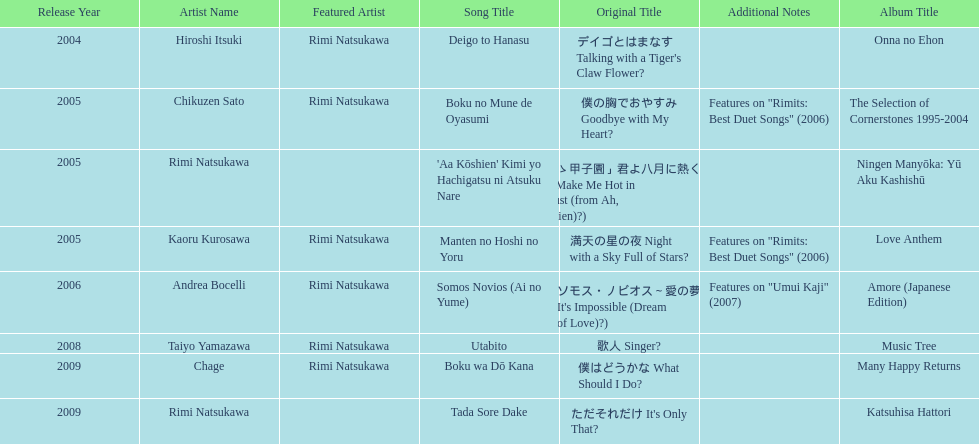Which title has the same notes as night with a sky full of stars? Boku no Mune de Oyasumi (僕の胸でおやすみ Goodbye with My Heart?). Parse the table in full. {'header': ['Release Year', 'Artist Name', 'Featured Artist', 'Song Title', 'Original Title', 'Additional Notes', 'Album Title'], 'rows': [['2004', 'Hiroshi Itsuki', 'Rimi Natsukawa', 'Deigo to Hanasu', "デイゴとはまなす Talking with a Tiger's Claw Flower?", '', 'Onna no Ehon'], ['2005', 'Chikuzen Sato', 'Rimi Natsukawa', 'Boku no Mune de Oyasumi', '僕の胸でおやすみ Goodbye with My Heart?', 'Features on "Rimits: Best Duet Songs" (2006)', 'The Selection of Cornerstones 1995-2004'], ['2005', 'Rimi Natsukawa', '', "'Aa Kōshien' Kimi yo Hachigatsu ni Atsuku Nare", '「あゝ甲子園」君よ八月に熱くなれ You Make Me Hot in August (from Ah, Kōshien)?)', '', 'Ningen Manyōka: Yū Aku Kashishū'], ['2005', 'Kaoru Kurosawa', 'Rimi Natsukawa', 'Manten no Hoshi no Yoru', '満天の星の夜 Night with a Sky Full of Stars?', 'Features on "Rimits: Best Duet Songs" (2006)', 'Love Anthem'], ['2006', 'Andrea Bocelli', 'Rimi Natsukawa', 'Somos Novios (Ai no Yume)', "ソモス・ノビオス～愛の夢 It's Impossible (Dream of Love)?)", 'Features on "Umui Kaji" (2007)', 'Amore (Japanese Edition)'], ['2008', 'Taiyo Yamazawa', 'Rimi Natsukawa', 'Utabito', '歌人 Singer?', '', 'Music Tree'], ['2009', 'Chage', 'Rimi Natsukawa', 'Boku wa Dō Kana', '僕はどうかな What Should I Do?', '', 'Many Happy Returns'], ['2009', 'Rimi Natsukawa', '', 'Tada Sore Dake', "ただそれだけ It's Only That?", '', 'Katsuhisa Hattori']]} 